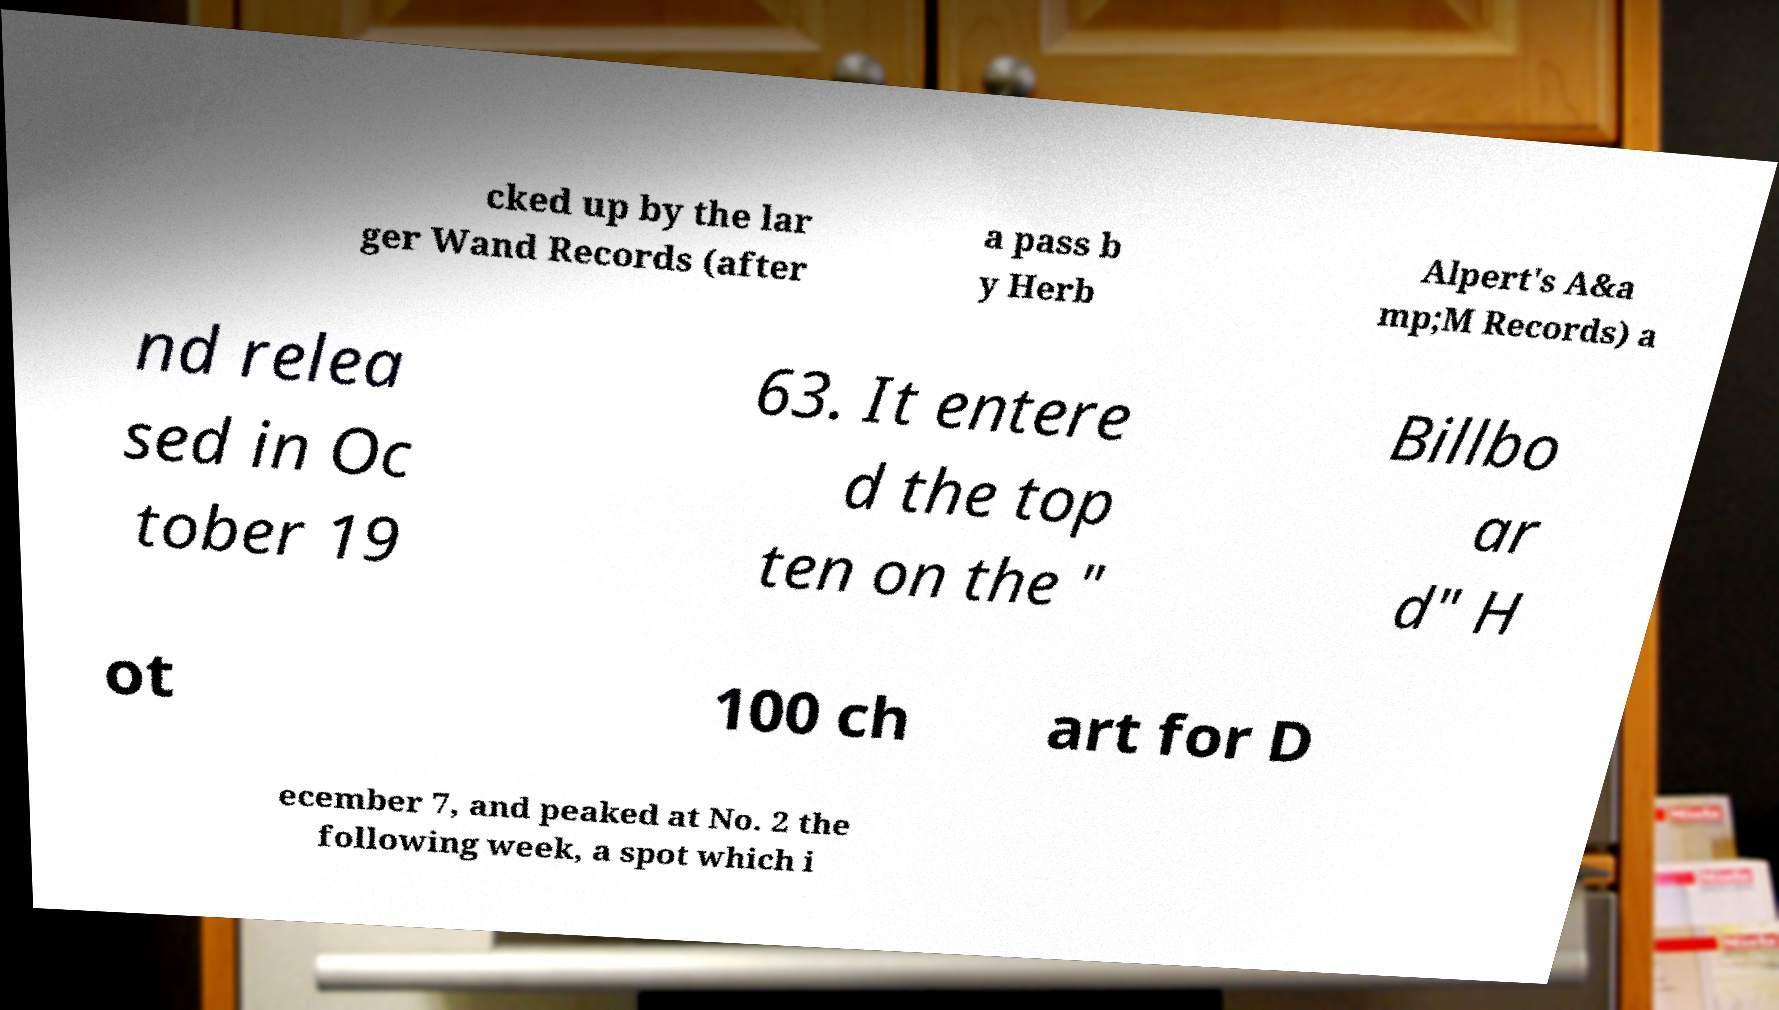For documentation purposes, I need the text within this image transcribed. Could you provide that? cked up by the lar ger Wand Records (after a pass b y Herb Alpert's A&a mp;M Records) a nd relea sed in Oc tober 19 63. It entere d the top ten on the " Billbo ar d" H ot 100 ch art for D ecember 7, and peaked at No. 2 the following week, a spot which i 